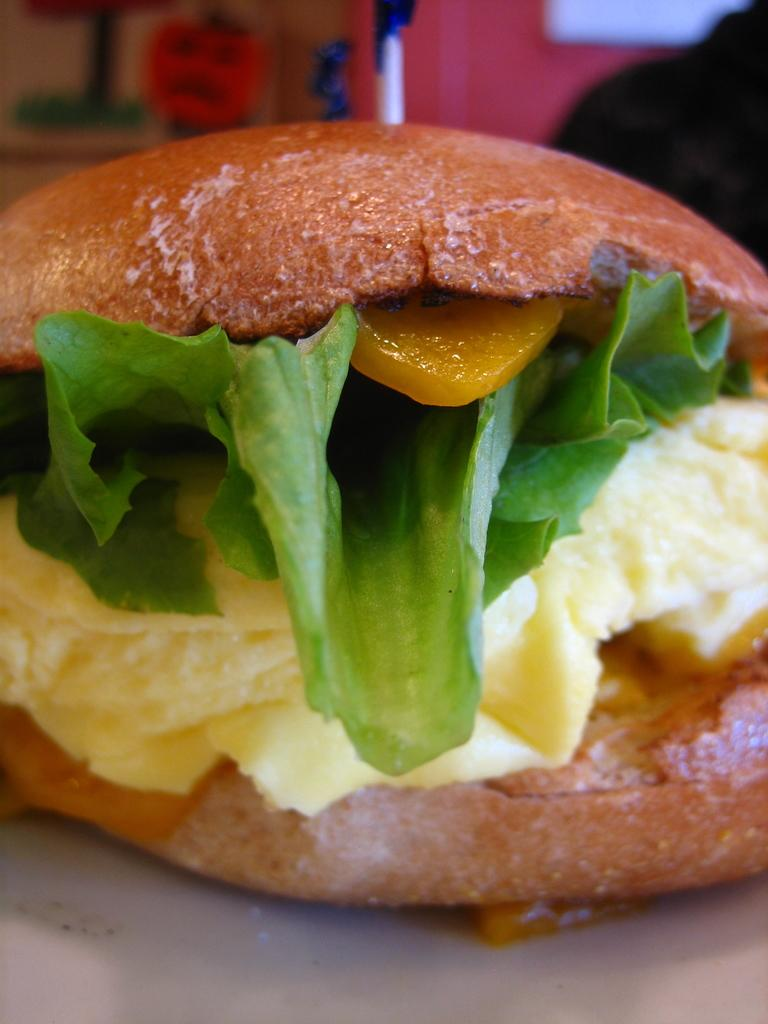What type of food is visible in the image? There is a burger in the image. Can you describe the appearance of the burger? The burger appears to be blurred in the background. How much money does the burger cough up in the image? There is no money or coughing depicted in the image; it only features a burger that is blurred in the background. 